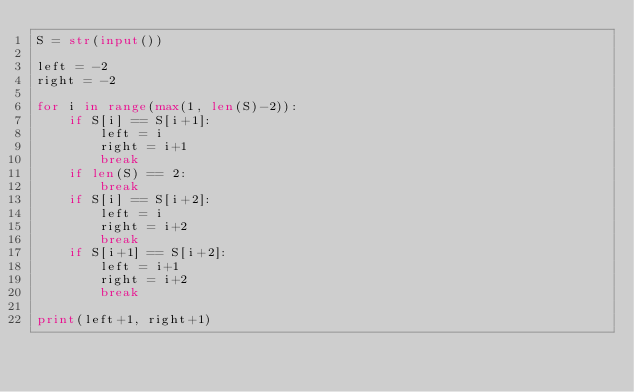Convert code to text. <code><loc_0><loc_0><loc_500><loc_500><_Python_>S = str(input())

left = -2
right = -2

for i in range(max(1, len(S)-2)):
    if S[i] == S[i+1]:
        left = i
        right = i+1
        break
    if len(S) == 2:
        break
    if S[i] == S[i+2]:
        left = i
        right = i+2
        break
    if S[i+1] == S[i+2]:
        left = i+1
        right = i+2
        break

print(left+1, right+1)
</code> 